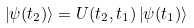<formula> <loc_0><loc_0><loc_500><loc_500>\left | \psi ( t _ { 2 } ) \right \rangle = U ( t _ { 2 } , t _ { 1 } ) \left | \psi ( t _ { 1 } ) \right \rangle</formula> 